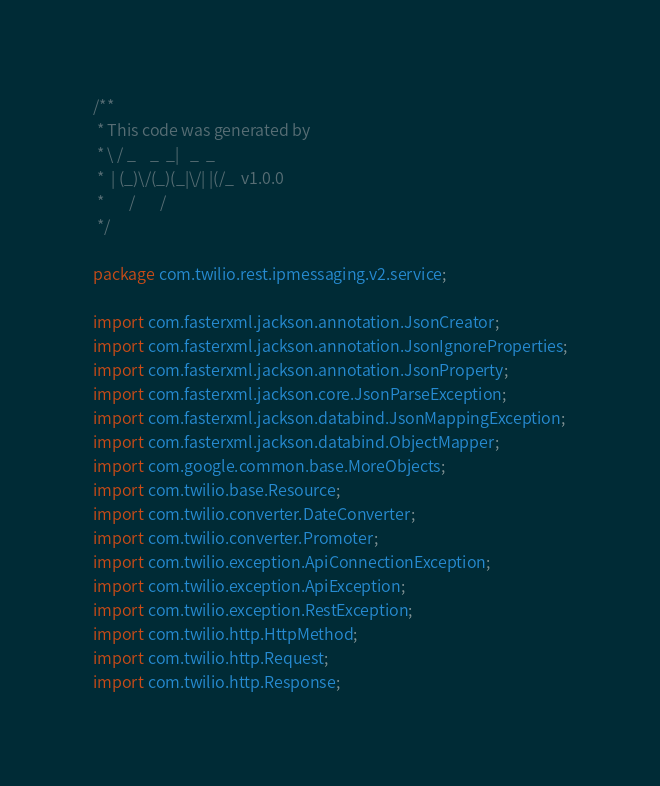Convert code to text. <code><loc_0><loc_0><loc_500><loc_500><_Java_>/**
 * This code was generated by
 * \ / _    _  _|   _  _
 *  | (_)\/(_)(_|\/| |(/_  v1.0.0
 *       /       /
 */

package com.twilio.rest.ipmessaging.v2.service;

import com.fasterxml.jackson.annotation.JsonCreator;
import com.fasterxml.jackson.annotation.JsonIgnoreProperties;
import com.fasterxml.jackson.annotation.JsonProperty;
import com.fasterxml.jackson.core.JsonParseException;
import com.fasterxml.jackson.databind.JsonMappingException;
import com.fasterxml.jackson.databind.ObjectMapper;
import com.google.common.base.MoreObjects;
import com.twilio.base.Resource;
import com.twilio.converter.DateConverter;
import com.twilio.converter.Promoter;
import com.twilio.exception.ApiConnectionException;
import com.twilio.exception.ApiException;
import com.twilio.exception.RestException;
import com.twilio.http.HttpMethod;
import com.twilio.http.Request;
import com.twilio.http.Response;</code> 